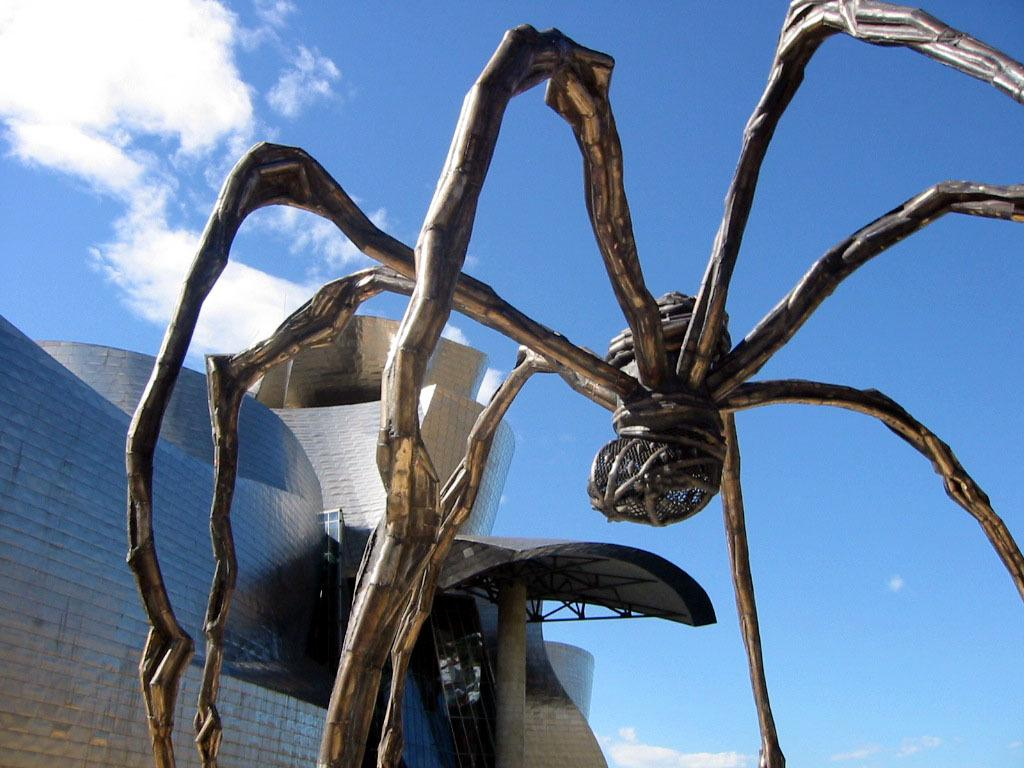What is the main subject of the image? The main subject of the image is a giant statue of a spider. Can you describe the background of the image? There is a huge architecture behind the statue. How many frogs can be seen sitting on the spider's legs in the image? There are no frogs present in the image; it features a giant statue of a spider and a huge architecture. What advice might the spider's aunt give in the image? There is no aunt mentioned in the image, as it only features a giant statue of a spider and a huge architecture. 